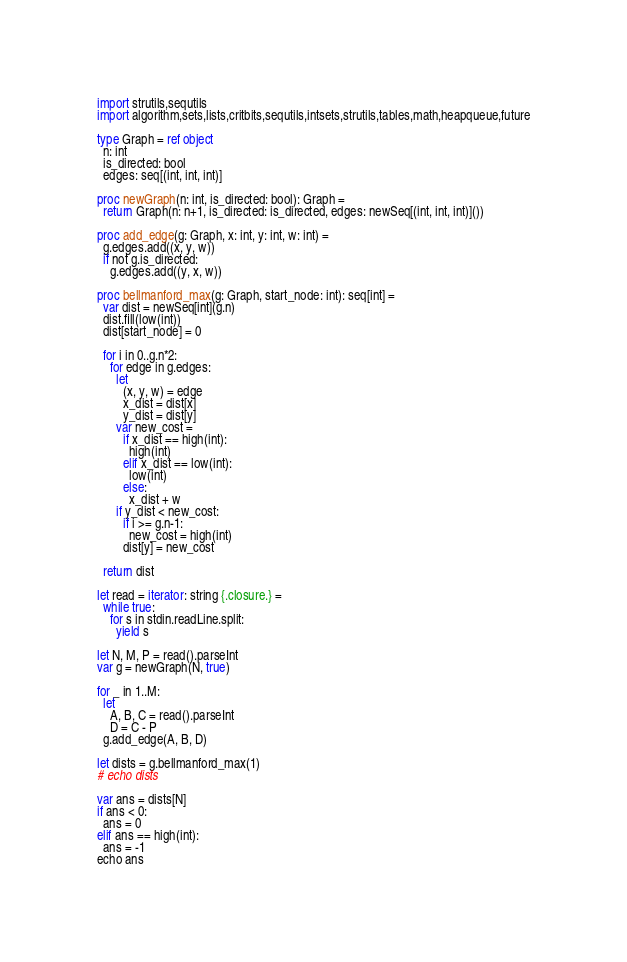Convert code to text. <code><loc_0><loc_0><loc_500><loc_500><_Nim_>import strutils,sequtils
import algorithm,sets,lists,critbits,sequtils,intsets,strutils,tables,math,heapqueue,future

type Graph = ref object
  n: int
  is_directed: bool
  edges: seq[(int, int, int)]

proc newGraph(n: int, is_directed: bool): Graph =
  return Graph(n: n+1, is_directed: is_directed, edges: newSeq[(int, int, int)]())

proc add_edge(g: Graph, x: int, y: int, w: int) =
  g.edges.add((x, y, w))
  if not g.is_directed:
    g.edges.add((y, x, w))

proc bellmanford_max(g: Graph, start_node: int): seq[int] =
  var dist = newSeq[int](g.n)
  dist.fill(low(int))
  dist[start_node] = 0

  for i in 0..g.n*2:
    for edge in g.edges:
      let
        (x, y, w) = edge
        x_dist = dist[x]
        y_dist = dist[y]
      var new_cost =
        if x_dist == high(int):
          high(int)
        elif x_dist == low(int):
          low(int)
        else:
          x_dist + w
      if y_dist < new_cost:
        if i >= g.n-1:
          new_cost = high(int)
        dist[y] = new_cost

  return dist

let read = iterator: string {.closure.} =
  while true:
    for s in stdin.readLine.split:
      yield s

let N, M, P = read().parseInt
var g = newGraph(N, true)

for _ in 1..M:
  let
    A, B, C = read().parseInt
    D = C - P
  g.add_edge(A, B, D)

let dists = g.bellmanford_max(1)
# echo dists

var ans = dists[N]
if ans < 0:
  ans = 0
elif ans == high(int):
  ans = -1
echo ans
</code> 